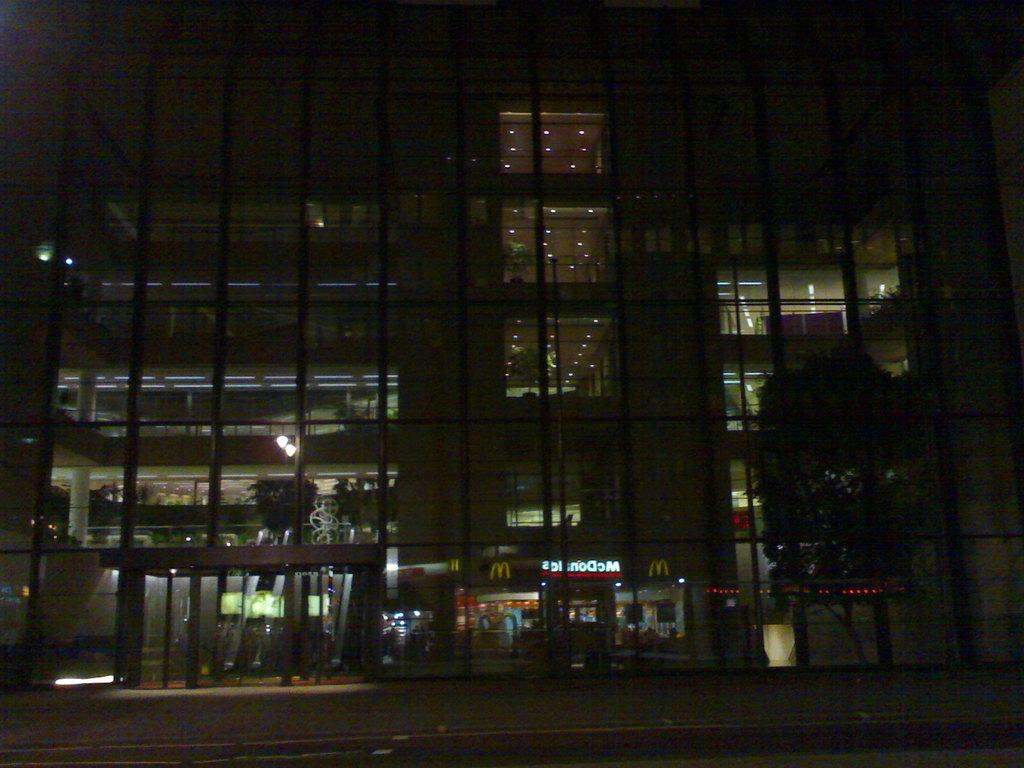What type of vegetation is on the right side of the image? There is a tree on the right side of the image. What kind of structure is located in the center of the image? There is a glass building in the center of the image. What can be seen at the bottom side of the image? It appears that there are stalls at the bottom side of the image. What is the profit made by the truck in the image? There is no truck present in the image, so it is not possible to determine any profit made. What type of spark can be seen coming from the tree in the image? There is no spark visible in the image, as it features a tree, a glass building, and stalls. 